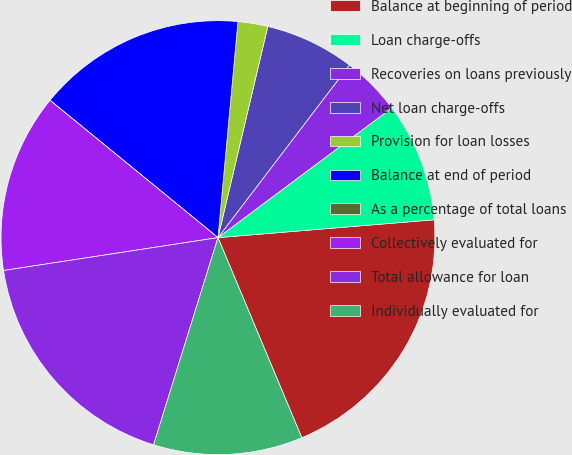<chart> <loc_0><loc_0><loc_500><loc_500><pie_chart><fcel>Balance at beginning of period<fcel>Loan charge-offs<fcel>Recoveries on loans previously<fcel>Net loan charge-offs<fcel>Provision for loan losses<fcel>Balance at end of period<fcel>As a percentage of total loans<fcel>Collectively evaluated for<fcel>Total allowance for loan<fcel>Individually evaluated for<nl><fcel>20.0%<fcel>8.89%<fcel>4.44%<fcel>6.67%<fcel>2.22%<fcel>15.56%<fcel>0.0%<fcel>13.33%<fcel>17.78%<fcel>11.11%<nl></chart> 